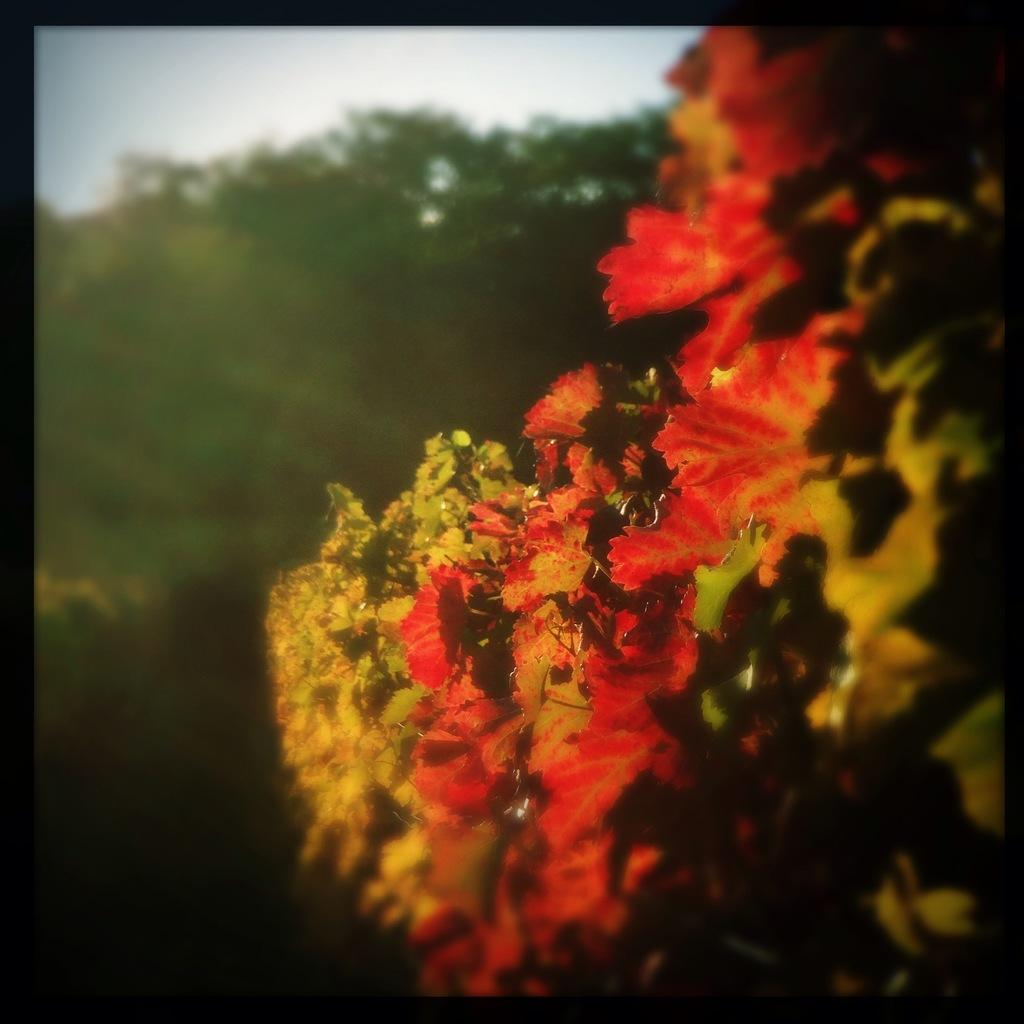What is the nature of the image? The image appears to be edited. What type of plants can be seen in the image? There are flowers in the image. What can be seen in the background of the image? There are trees and the sky visible in the background of the image. Where is the throne located in the image? There is no throne present in the image. What type of paint is used to create the flowers in the image? The image appears to be edited, so it is not possible to determine the type of paint used to create the flowers. 